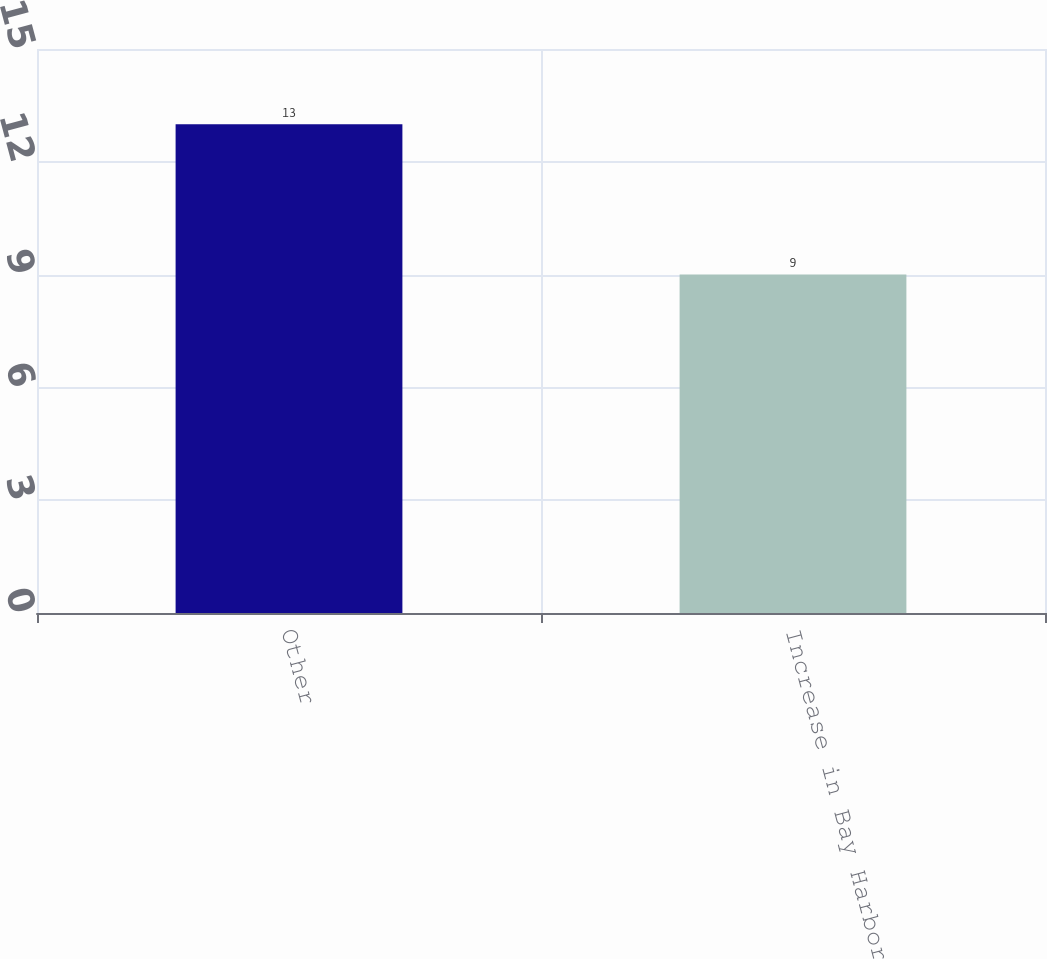Convert chart. <chart><loc_0><loc_0><loc_500><loc_500><bar_chart><fcel>Other<fcel>Increase in Bay Harbor<nl><fcel>13<fcel>9<nl></chart> 